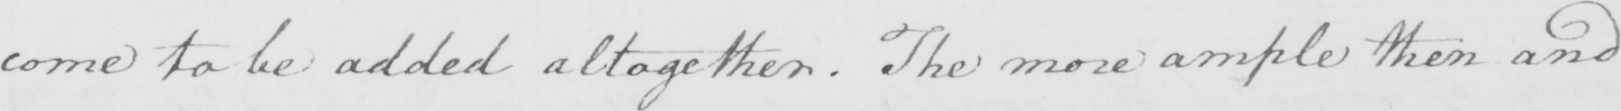What is written in this line of handwriting? come to be added altogether. The more ample then and 